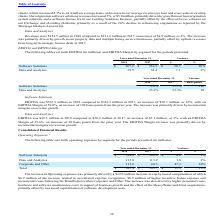According to Black Knight Financial Services's financial document, What was increase in EBITDA for Software Solutions? According to the financial document, 50.7 (in millions). The relevant text states: "Software Solutions $ 567.2 $ 516.5 $ 50.7 10%..." Also, What was the increase in the EBITDA for Data and Analytics? According to the financial document, 1.1 (in millions). The relevant text states: "Data and Analytics 39.5 38.4 1.1 3%..." Also, Which years does the table provide information for the EBITDA by segment? The document shows two values: 2018 and 2017. From the document: "2018 2017 $ % 2018 2017 $ %..." Also, How many years did EBITDA for Software Solutions exceed $500 million? Counting the relevant items in the document: 2018, 2017, I find 2 instances. The key data points involved are: 2017, 2018. Also, can you calculate: What was the sum of the EBITDA in 2018? Based on the calculation: 567.2+39.5, the result is 606.7 (in millions). This is based on the information: "Data and Analytics 39.5 38.4 1.1 3% Software Solutions $ 567.2 $ 516.5 $ 50.7 10%..." The key data points involved are: 39.5, 567.2. Additionally, Which segments did the percent variance exceed 5%? According to the financial document, Software Solutions. The relevant text states: "cross-sales to existing clients. Our origination software solutions revenues increased 3%, or $5.0 million, primarily driven by growth in our loan origination system s..." 